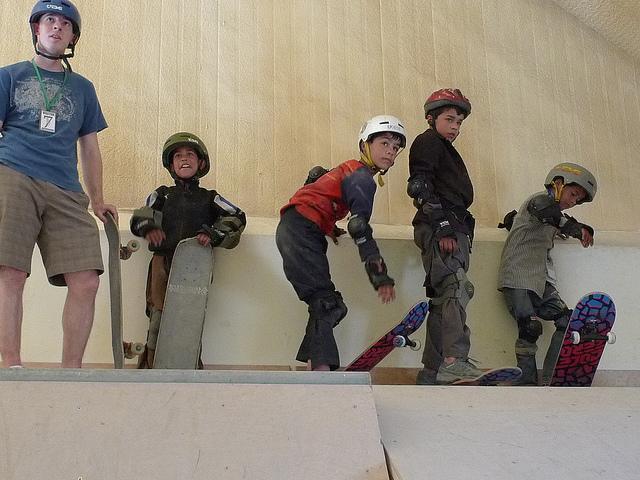How many of them are wearing helmets?
Give a very brief answer. 5. How many skateboards are touching the ground?
Give a very brief answer. 4. How many people are visible?
Give a very brief answer. 5. How many skateboards are visible?
Give a very brief answer. 4. 